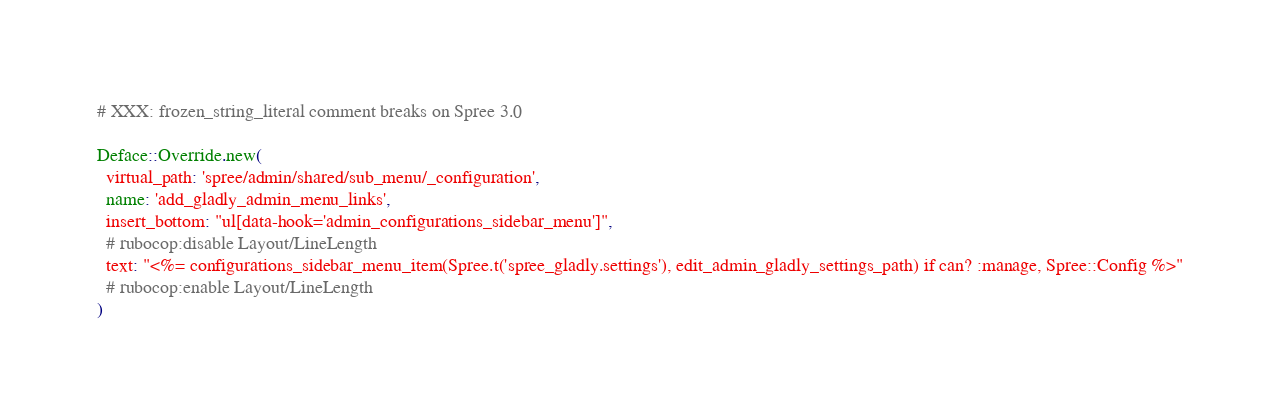Convert code to text. <code><loc_0><loc_0><loc_500><loc_500><_Ruby_># XXX: frozen_string_literal comment breaks on Spree 3.0

Deface::Override.new(
  virtual_path: 'spree/admin/shared/sub_menu/_configuration',
  name: 'add_gladly_admin_menu_links',
  insert_bottom: "ul[data-hook='admin_configurations_sidebar_menu']",
  # rubocop:disable Layout/LineLength
  text: "<%= configurations_sidebar_menu_item(Spree.t('spree_gladly.settings'), edit_admin_gladly_settings_path) if can? :manage, Spree::Config %>"
  # rubocop:enable Layout/LineLength
)
</code> 